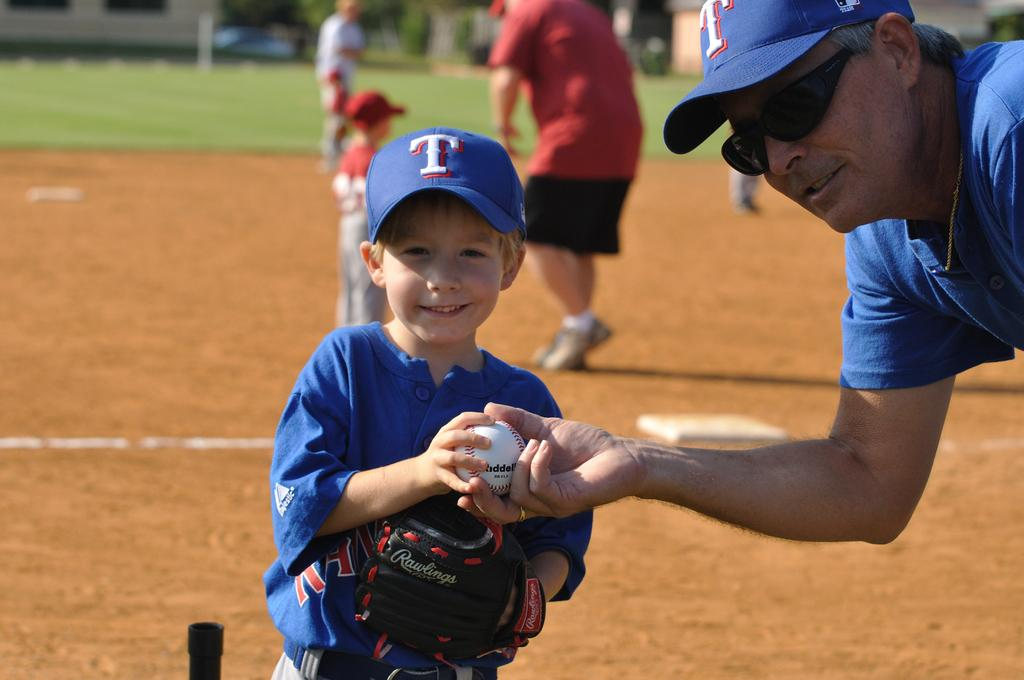Provide a one-sentence caption for the provided image. A man hands a baseball to a young boy wearing a blue hat with a white T on it. 